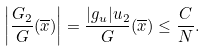Convert formula to latex. <formula><loc_0><loc_0><loc_500><loc_500>\left | \frac { G _ { 2 } } { G } ( \overline { x } ) \right | = \frac { | g _ { u } | u _ { 2 } } { G } ( \overline { x } ) \leq \frac { C } { N } .</formula> 